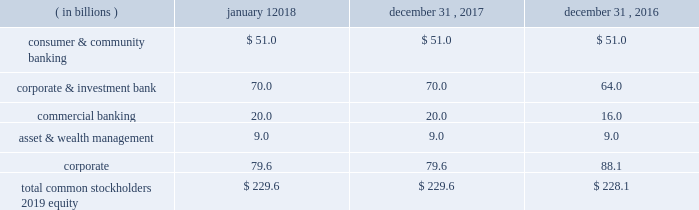Jpmorgan chase & co./2017 annual report 89 the table below reflects the firm 2019s assessed level of capital allocated to each line of business as of the dates indicated .
Line of business equity ( allocated capital ) .
Planning and stress testing comprehensive capital analysis and review the federal reserve requires large bank holding companies , including the firm , to submit a capital plan on an annual basis .
The federal reserve uses the ccar and dodd-frank act stress test processes to ensure that large bhcs have sufficient capital during periods of economic and financial stress , and have robust , forward-looking capital assessment and planning processes in place that address each bhc 2019s unique risks to enable it to absorb losses under certain stress scenarios .
Through the ccar , the federal reserve evaluates each bhc 2019s capital adequacy and internal capital adequacy assessment processes ( 201cicaap 201d ) , as well as its plans to make capital distributions , such as dividend payments or stock repurchases .
On june 28 , 2017 , the federal reserve informed the firm that it did not object , on either a quantitative or qualitative basis , to the firm 2019s 2017 capital plan .
For information on actions taken by the firm 2019s board of directors following the 2017 ccar results , see capital actions on pages 89-90 .
The firm 2019s ccar process is integrated into and employs the same methodologies utilized in the firm 2019s icaap process , as discussed below .
Internal capital adequacy assessment process semiannually , the firm completes the icaap , which provides management with a view of the impact of severe and unexpected events on earnings , balance sheet positions , reserves and capital .
The firm 2019s icaap integrates stress testing protocols with capital planning .
The process assesses the potential impact of alternative economic and business scenarios on the firm 2019s earnings and capital .
Economic scenarios , and the parameters underlying those scenarios , are defined centrally and applied uniformly across the businesses .
These scenarios are articulated in terms of macroeconomic factors , which are key drivers of business results ; global market shocks , which generate short-term but severe trading losses ; and idiosyncratic operational risk events .
The scenarios are intended to capture and stress key vulnerabilities and idiosyncratic risks facing the firm .
However , when defining a broad range of scenarios , actual events can always be worse .
Accordingly , management considers additional stresses outside these scenarios , as necessary .
Icaap results are reviewed by management and the audit committee .
Capital actions preferred stock preferred stock dividends declared were $ 1.7 billion for the year ended december 31 , 2017 .
On october 20 , 2017 , the firm issued $ 1.3 billion of fixed- to-floating rate non-cumulative preferred stock , series cc , with an initial dividend rate of 4.625% ( 4.625 % ) .
On december 1 , 2017 , the firm redeemed all $ 1.3 billion of its outstanding 5.50% ( 5.50 % ) non-cumulative preferred stock , series o .
For additional information on the firm 2019s preferred stock , see note 20 .
Trust preferred securities on december 18 , 2017 , the delaware trusts that issued seven series of outstanding trust preferred securities were liquidated , $ 1.6 billion of trust preferred and $ 56 million of common securities originally issued by those trusts were cancelled , and the junior subordinated debentures previously held by each trust issuer were distributed pro rata to the holders of the corresponding series of trust preferred and common securities .
The firm redeemed $ 1.6 billion of trust preferred securities in the year ended december 31 , 2016 .
Common stock dividends the firm 2019s common stock dividend policy reflects jpmorgan chase 2019s earnings outlook , desired dividend payout ratio , capital objectives , and alternative investment opportunities .
On september 19 , 2017 , the firm announced that its board of directors increased the quarterly common stock dividend to $ 0.56 per share , effective with the dividend paid on october 31 , 2017 .
The firm 2019s dividends are subject to the board of directors 2019 approval on a quarterly basis .
For information regarding dividend restrictions , see note 20 and note 25. .
What is the annual cash flow cost of the cc series preferred stock , in m? 
Rationale: using dividend rate times face amount
Computations: ((1.3 * 4.625%) * 1000)
Answer: 60.125. 